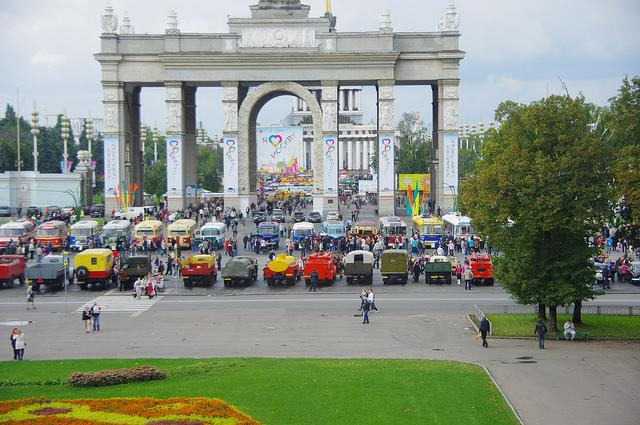The signs are expressing their love for which city? paris 